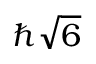<formula> <loc_0><loc_0><loc_500><loc_500>\hbar { \sqrt { 6 } }</formula> 